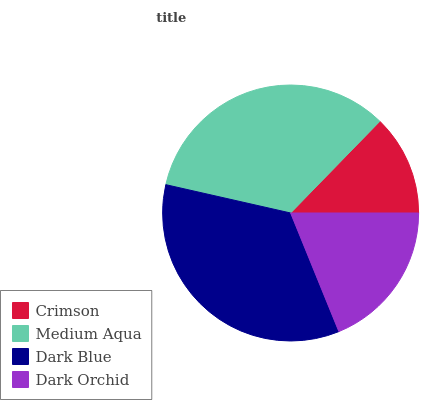Is Crimson the minimum?
Answer yes or no. Yes. Is Dark Blue the maximum?
Answer yes or no. Yes. Is Medium Aqua the minimum?
Answer yes or no. No. Is Medium Aqua the maximum?
Answer yes or no. No. Is Medium Aqua greater than Crimson?
Answer yes or no. Yes. Is Crimson less than Medium Aqua?
Answer yes or no. Yes. Is Crimson greater than Medium Aqua?
Answer yes or no. No. Is Medium Aqua less than Crimson?
Answer yes or no. No. Is Medium Aqua the high median?
Answer yes or no. Yes. Is Dark Orchid the low median?
Answer yes or no. Yes. Is Dark Blue the high median?
Answer yes or no. No. Is Dark Blue the low median?
Answer yes or no. No. 